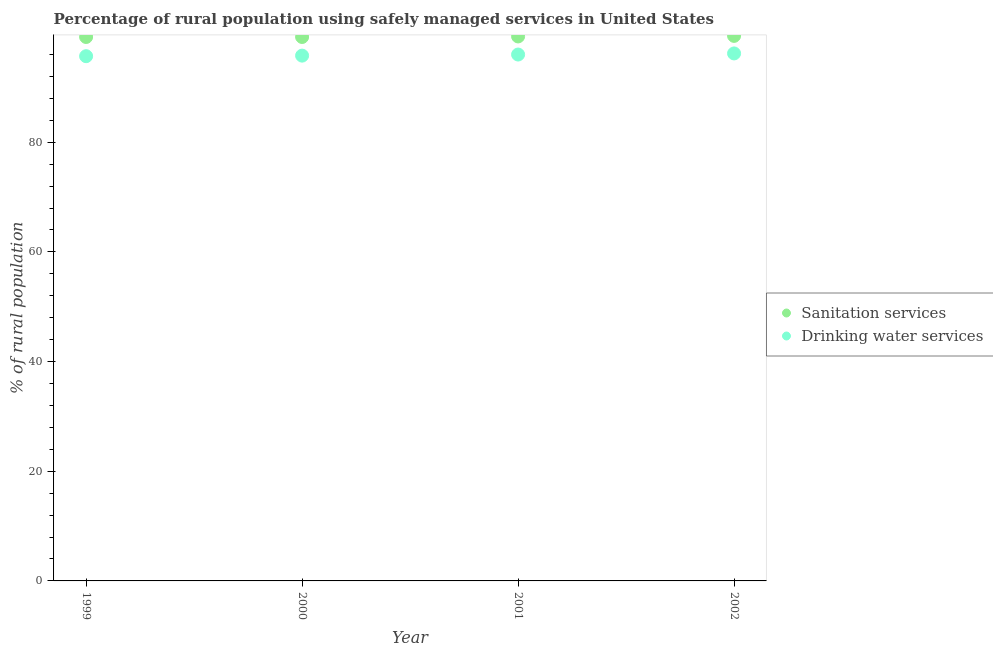What is the percentage of rural population who used sanitation services in 1999?
Offer a very short reply. 99.2. Across all years, what is the maximum percentage of rural population who used sanitation services?
Your response must be concise. 99.4. Across all years, what is the minimum percentage of rural population who used drinking water services?
Offer a very short reply. 95.7. In which year was the percentage of rural population who used sanitation services minimum?
Keep it short and to the point. 1999. What is the total percentage of rural population who used sanitation services in the graph?
Provide a short and direct response. 397.1. What is the difference between the percentage of rural population who used drinking water services in 1999 and that in 2000?
Your answer should be compact. -0.1. What is the difference between the percentage of rural population who used drinking water services in 2002 and the percentage of rural population who used sanitation services in 2000?
Your answer should be very brief. -3. What is the average percentage of rural population who used drinking water services per year?
Your answer should be compact. 95.92. In the year 2001, what is the difference between the percentage of rural population who used drinking water services and percentage of rural population who used sanitation services?
Give a very brief answer. -3.3. What is the ratio of the percentage of rural population who used drinking water services in 2001 to that in 2002?
Offer a terse response. 1. What is the difference between the highest and the second highest percentage of rural population who used sanitation services?
Your answer should be compact. 0.1. What is the difference between the highest and the lowest percentage of rural population who used drinking water services?
Offer a very short reply. 0.5. In how many years, is the percentage of rural population who used drinking water services greater than the average percentage of rural population who used drinking water services taken over all years?
Ensure brevity in your answer.  2. Does the percentage of rural population who used sanitation services monotonically increase over the years?
Offer a very short reply. No. Is the percentage of rural population who used drinking water services strictly greater than the percentage of rural population who used sanitation services over the years?
Offer a very short reply. No. Is the percentage of rural population who used sanitation services strictly less than the percentage of rural population who used drinking water services over the years?
Offer a very short reply. No. How many dotlines are there?
Offer a very short reply. 2. Does the graph contain any zero values?
Your answer should be very brief. No. How are the legend labels stacked?
Keep it short and to the point. Vertical. What is the title of the graph?
Make the answer very short. Percentage of rural population using safely managed services in United States. Does "Highest 20% of population" appear as one of the legend labels in the graph?
Give a very brief answer. No. What is the label or title of the Y-axis?
Your answer should be very brief. % of rural population. What is the % of rural population of Sanitation services in 1999?
Give a very brief answer. 99.2. What is the % of rural population of Drinking water services in 1999?
Your answer should be compact. 95.7. What is the % of rural population of Sanitation services in 2000?
Your answer should be compact. 99.2. What is the % of rural population of Drinking water services in 2000?
Offer a very short reply. 95.8. What is the % of rural population of Sanitation services in 2001?
Offer a very short reply. 99.3. What is the % of rural population of Drinking water services in 2001?
Give a very brief answer. 96. What is the % of rural population of Sanitation services in 2002?
Make the answer very short. 99.4. What is the % of rural population in Drinking water services in 2002?
Provide a succinct answer. 96.2. Across all years, what is the maximum % of rural population in Sanitation services?
Keep it short and to the point. 99.4. Across all years, what is the maximum % of rural population of Drinking water services?
Your answer should be very brief. 96.2. Across all years, what is the minimum % of rural population of Sanitation services?
Offer a very short reply. 99.2. Across all years, what is the minimum % of rural population in Drinking water services?
Provide a succinct answer. 95.7. What is the total % of rural population in Sanitation services in the graph?
Your answer should be very brief. 397.1. What is the total % of rural population of Drinking water services in the graph?
Give a very brief answer. 383.7. What is the difference between the % of rural population of Drinking water services in 1999 and that in 2002?
Keep it short and to the point. -0.5. What is the difference between the % of rural population in Sanitation services in 1999 and the % of rural population in Drinking water services in 2000?
Your answer should be compact. 3.4. What is the difference between the % of rural population of Sanitation services in 1999 and the % of rural population of Drinking water services in 2001?
Make the answer very short. 3.2. What is the difference between the % of rural population in Sanitation services in 1999 and the % of rural population in Drinking water services in 2002?
Give a very brief answer. 3. What is the difference between the % of rural population of Sanitation services in 2000 and the % of rural population of Drinking water services in 2001?
Give a very brief answer. 3.2. What is the average % of rural population of Sanitation services per year?
Offer a very short reply. 99.28. What is the average % of rural population in Drinking water services per year?
Make the answer very short. 95.92. In the year 1999, what is the difference between the % of rural population of Sanitation services and % of rural population of Drinking water services?
Your answer should be very brief. 3.5. What is the ratio of the % of rural population in Sanitation services in 1999 to that in 2001?
Make the answer very short. 1. What is the ratio of the % of rural population in Drinking water services in 1999 to that in 2002?
Your response must be concise. 0.99. What is the ratio of the % of rural population of Drinking water services in 2000 to that in 2001?
Your answer should be compact. 1. What is the ratio of the % of rural population in Sanitation services in 2000 to that in 2002?
Your response must be concise. 1. What is the ratio of the % of rural population of Sanitation services in 2001 to that in 2002?
Ensure brevity in your answer.  1. What is the difference between the highest and the second highest % of rural population of Sanitation services?
Your answer should be compact. 0.1. What is the difference between the highest and the lowest % of rural population of Sanitation services?
Make the answer very short. 0.2. What is the difference between the highest and the lowest % of rural population in Drinking water services?
Provide a short and direct response. 0.5. 